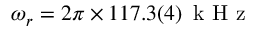Convert formula to latex. <formula><loc_0><loc_0><loc_500><loc_500>\omega _ { r } = 2 \pi \times 1 1 7 . 3 ( 4 ) \, k H z</formula> 